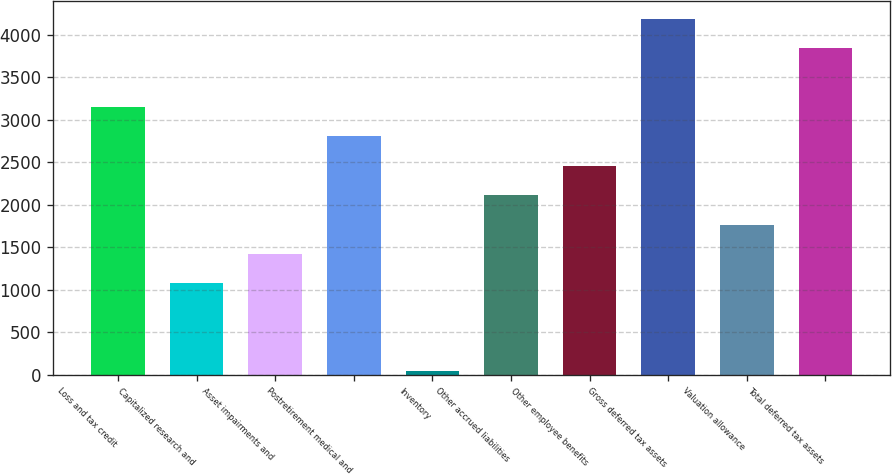<chart> <loc_0><loc_0><loc_500><loc_500><bar_chart><fcel>Loss and tax credit<fcel>Capitalized research and<fcel>Asset impairments and<fcel>Postretirement medical and<fcel>Inventory<fcel>Other accrued liabilities<fcel>Other employee benefits<fcel>Gross deferred tax assets<fcel>Valuation allowance<fcel>Total deferred tax assets<nl><fcel>3149.2<fcel>1074.4<fcel>1420.2<fcel>2803.4<fcel>37<fcel>2111.8<fcel>2457.6<fcel>4186.6<fcel>1766<fcel>3840.8<nl></chart> 